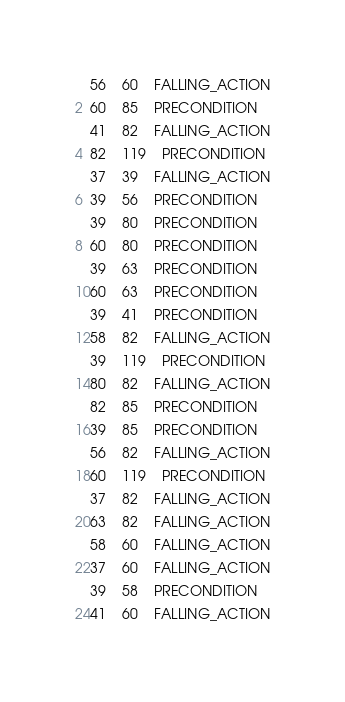Convert code to text. <code><loc_0><loc_0><loc_500><loc_500><_SQL_>56	60	FALLING_ACTION
60	85	PRECONDITION
41	82	FALLING_ACTION
82	119	PRECONDITION
37	39	FALLING_ACTION
39	56	PRECONDITION
39	80	PRECONDITION
60	80	PRECONDITION
39	63	PRECONDITION
60	63	PRECONDITION
39	41	PRECONDITION
58	82	FALLING_ACTION
39	119	PRECONDITION
80	82	FALLING_ACTION
82	85	PRECONDITION
39	85	PRECONDITION
56	82	FALLING_ACTION
60	119	PRECONDITION
37	82	FALLING_ACTION
63	82	FALLING_ACTION
58	60	FALLING_ACTION
37	60	FALLING_ACTION
39	58	PRECONDITION
41	60	FALLING_ACTION
</code> 